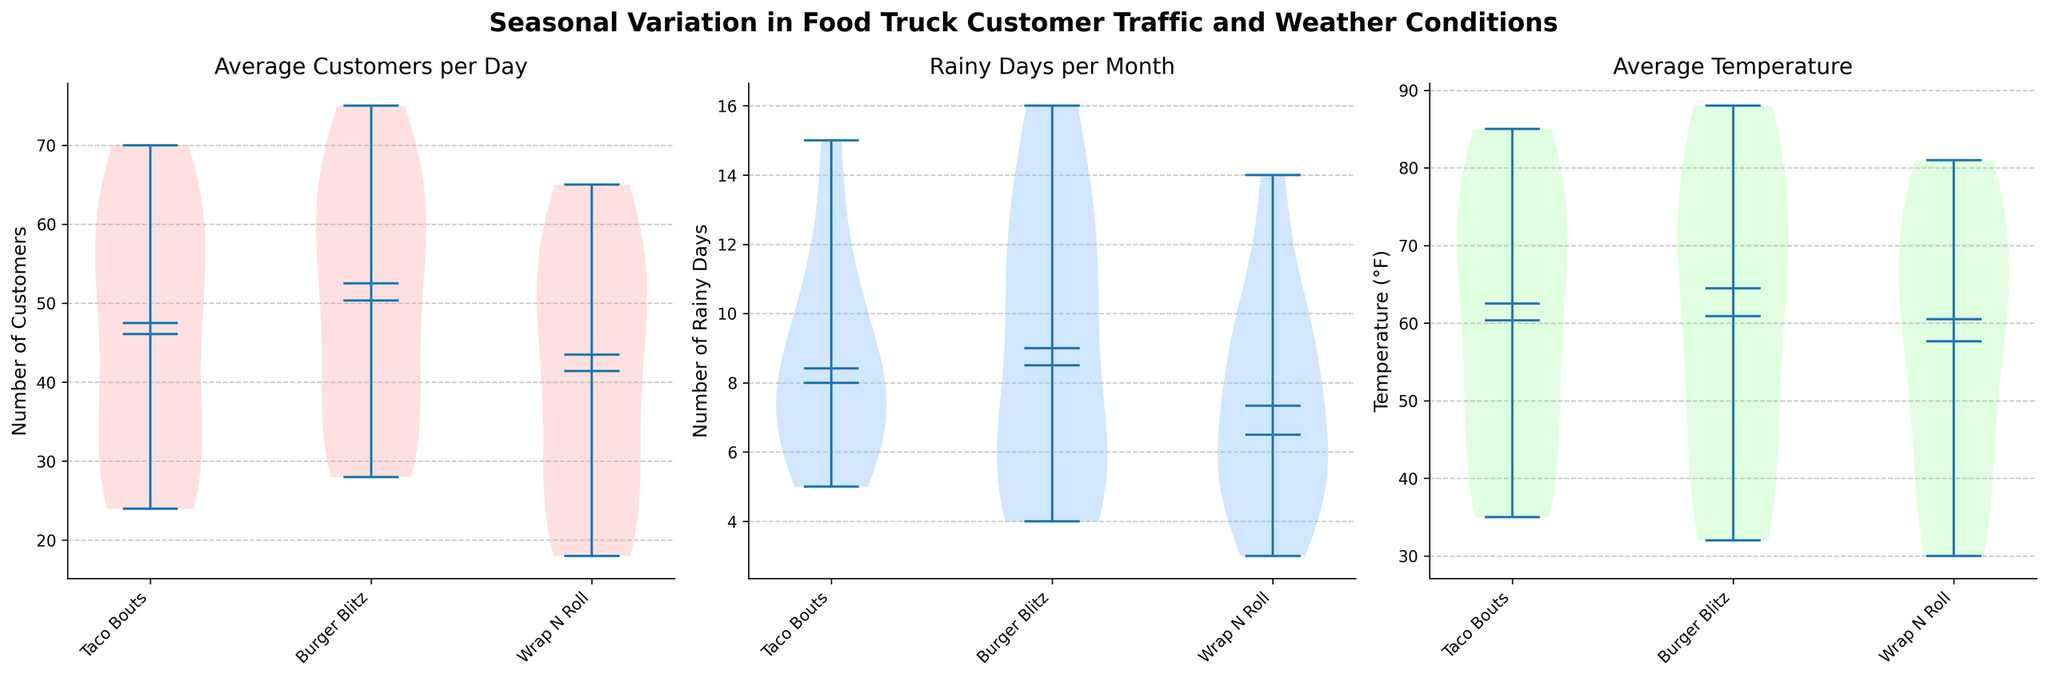What is the title of the figure? The title is displayed at the top of the figure, and it reads "Seasonal Variation in Food Truck Customer Traffic and Weather Conditions."
Answer: Seasonal Variation in Food Truck Customer Traffic and Weather Conditions Which food truck has the highest median number of average customers per day? By examining the violin plots for each food truck in the first subplot ("Average Customers per Day"), we can see that Burger Blitz has the highest median line.
Answer: Burger Blitz How does the number of rainy days per month vary across the food trucks? The second subplot shows the violin plots for rainy days per month for each food truck. The distributions appear quite similar, with Burger Blitz having slightly more variation and slightly higher means.
Answer: Similar, slight variation Which food truck has the highest average temperature? From the third subplot ("Average Temperature"), we see that the median line for Burger Blitz is slightly higher than those for Taco Bouts and Wrap N Roll.
Answer: Burger Blitz What is the mean number of average customers per day for Wrap N Roll? In the first subplot, the mean is indicated by the white dot within the violin chart. For Wrap N Roll, this white dot is lower compared to the other food trucks, reflecting a lower mean.
Answer: Lower mean Which food truck has the smallest spread of average temperature values? The spread of temperature values can be seen in the width of the violin plots. In the "Average Temperature" subplot, Taco Bouts has the narrowest violin plot, indicating the smallest spread of values.
Answer: Taco Bouts How many food trucks are compared in the figure? Each subplot is divided into three sections, each representing one of the three food trucks. This indicates that three food trucks are being compared.
Answer: Three Which month has the lowest average temperature across all food trucks? Inspecting the "Average Temperature" violin plots, December appears to have the lowest mean average temperature, as shown by the position of the white dots for all food trucks.
Answer: December 